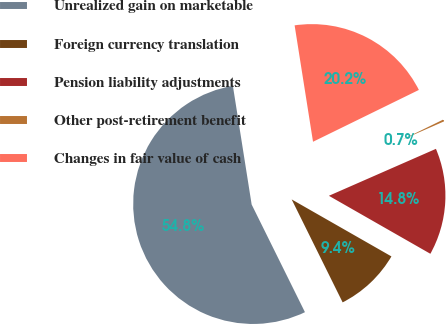Convert chart. <chart><loc_0><loc_0><loc_500><loc_500><pie_chart><fcel>Unrealized gain on marketable<fcel>Foreign currency translation<fcel>Pension liability adjustments<fcel>Other post-retirement benefit<fcel>Changes in fair value of cash<nl><fcel>54.82%<fcel>9.42%<fcel>14.84%<fcel>0.67%<fcel>20.25%<nl></chart> 